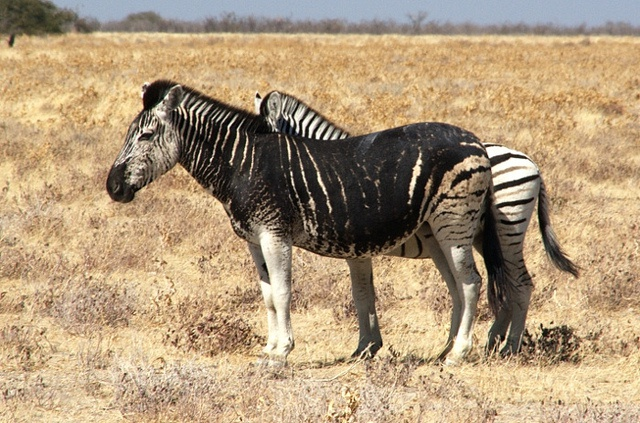Describe the objects in this image and their specific colors. I can see zebra in gray, black, and beige tones and zebra in gray, black, and ivory tones in this image. 